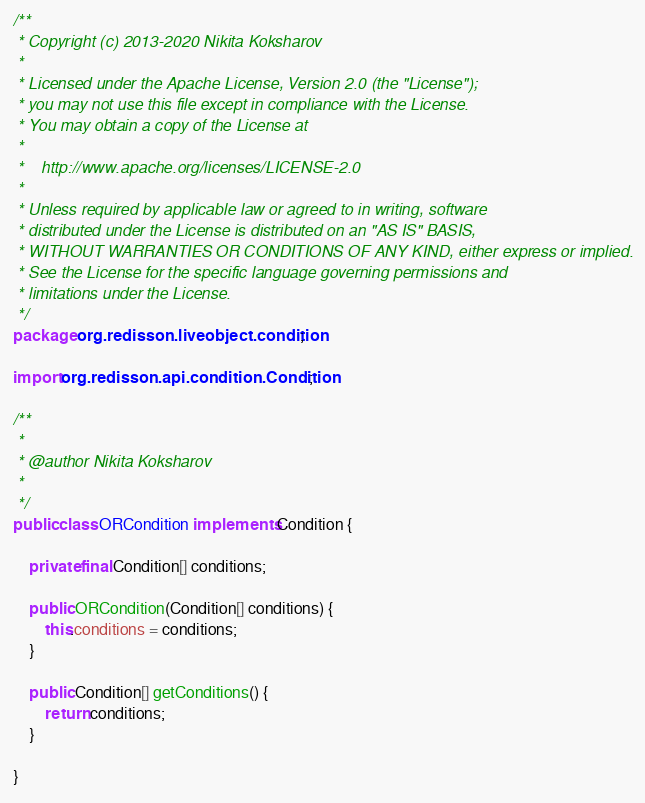<code> <loc_0><loc_0><loc_500><loc_500><_Java_>/**
 * Copyright (c) 2013-2020 Nikita Koksharov
 *
 * Licensed under the Apache License, Version 2.0 (the "License");
 * you may not use this file except in compliance with the License.
 * You may obtain a copy of the License at
 *
 *    http://www.apache.org/licenses/LICENSE-2.0
 *
 * Unless required by applicable law or agreed to in writing, software
 * distributed under the License is distributed on an "AS IS" BASIS,
 * WITHOUT WARRANTIES OR CONDITIONS OF ANY KIND, either express or implied.
 * See the License for the specific language governing permissions and
 * limitations under the License.
 */
package org.redisson.liveobject.condition;

import org.redisson.api.condition.Condition;

/**
 * 
 * @author Nikita Koksharov
 *
 */
public class ORCondition implements Condition {
    
    private final Condition[] conditions;

    public ORCondition(Condition[] conditions) {
        this.conditions = conditions;
    }

    public Condition[] getConditions() {
        return conditions;
    }
    
}
</code> 